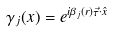Convert formula to latex. <formula><loc_0><loc_0><loc_500><loc_500>\gamma _ { j } ( x ) = e ^ { i \beta _ { j } ( r ) \vec { \tau } \cdot \hat { x } }</formula> 